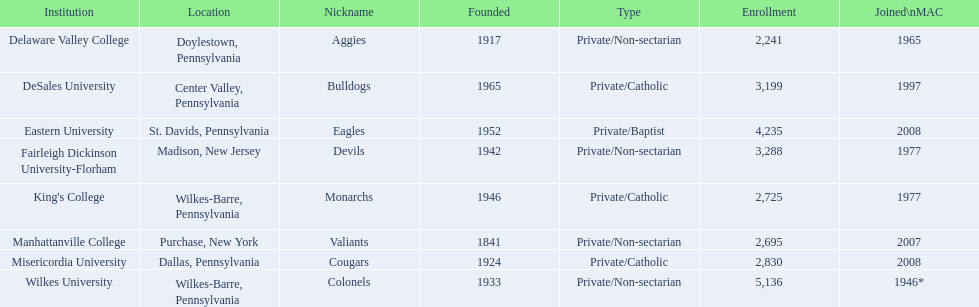List every organization with admission counts surpassing 4,000? Eastern University, Wilkes University. 